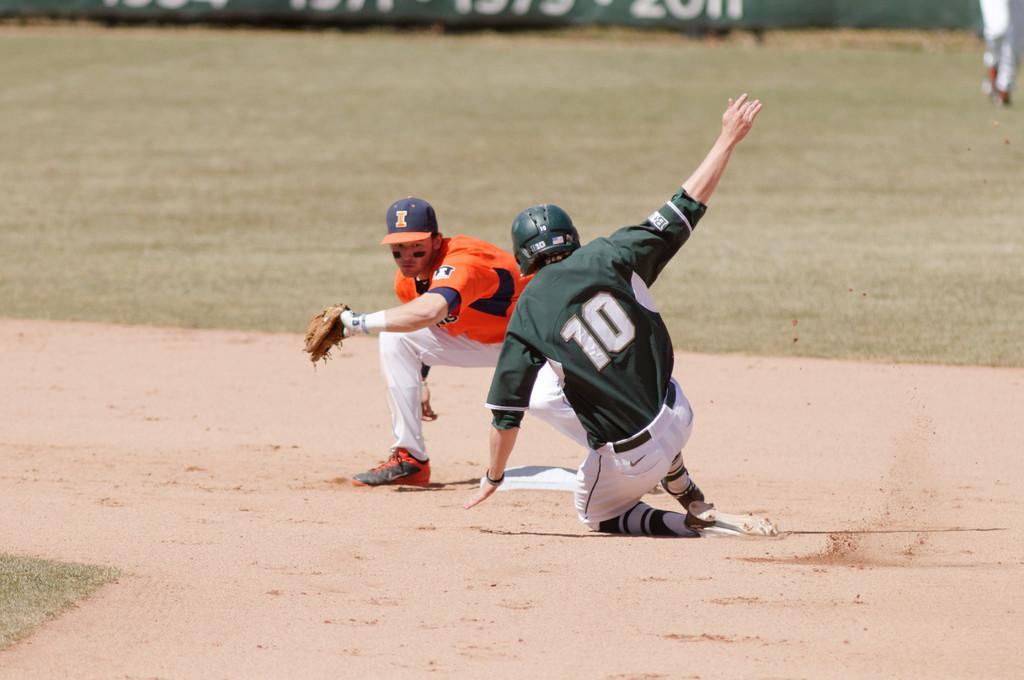Provide a one-sentence caption for the provided image. A baseball player wearing a green and white uniform and the number 10 slides into base. 